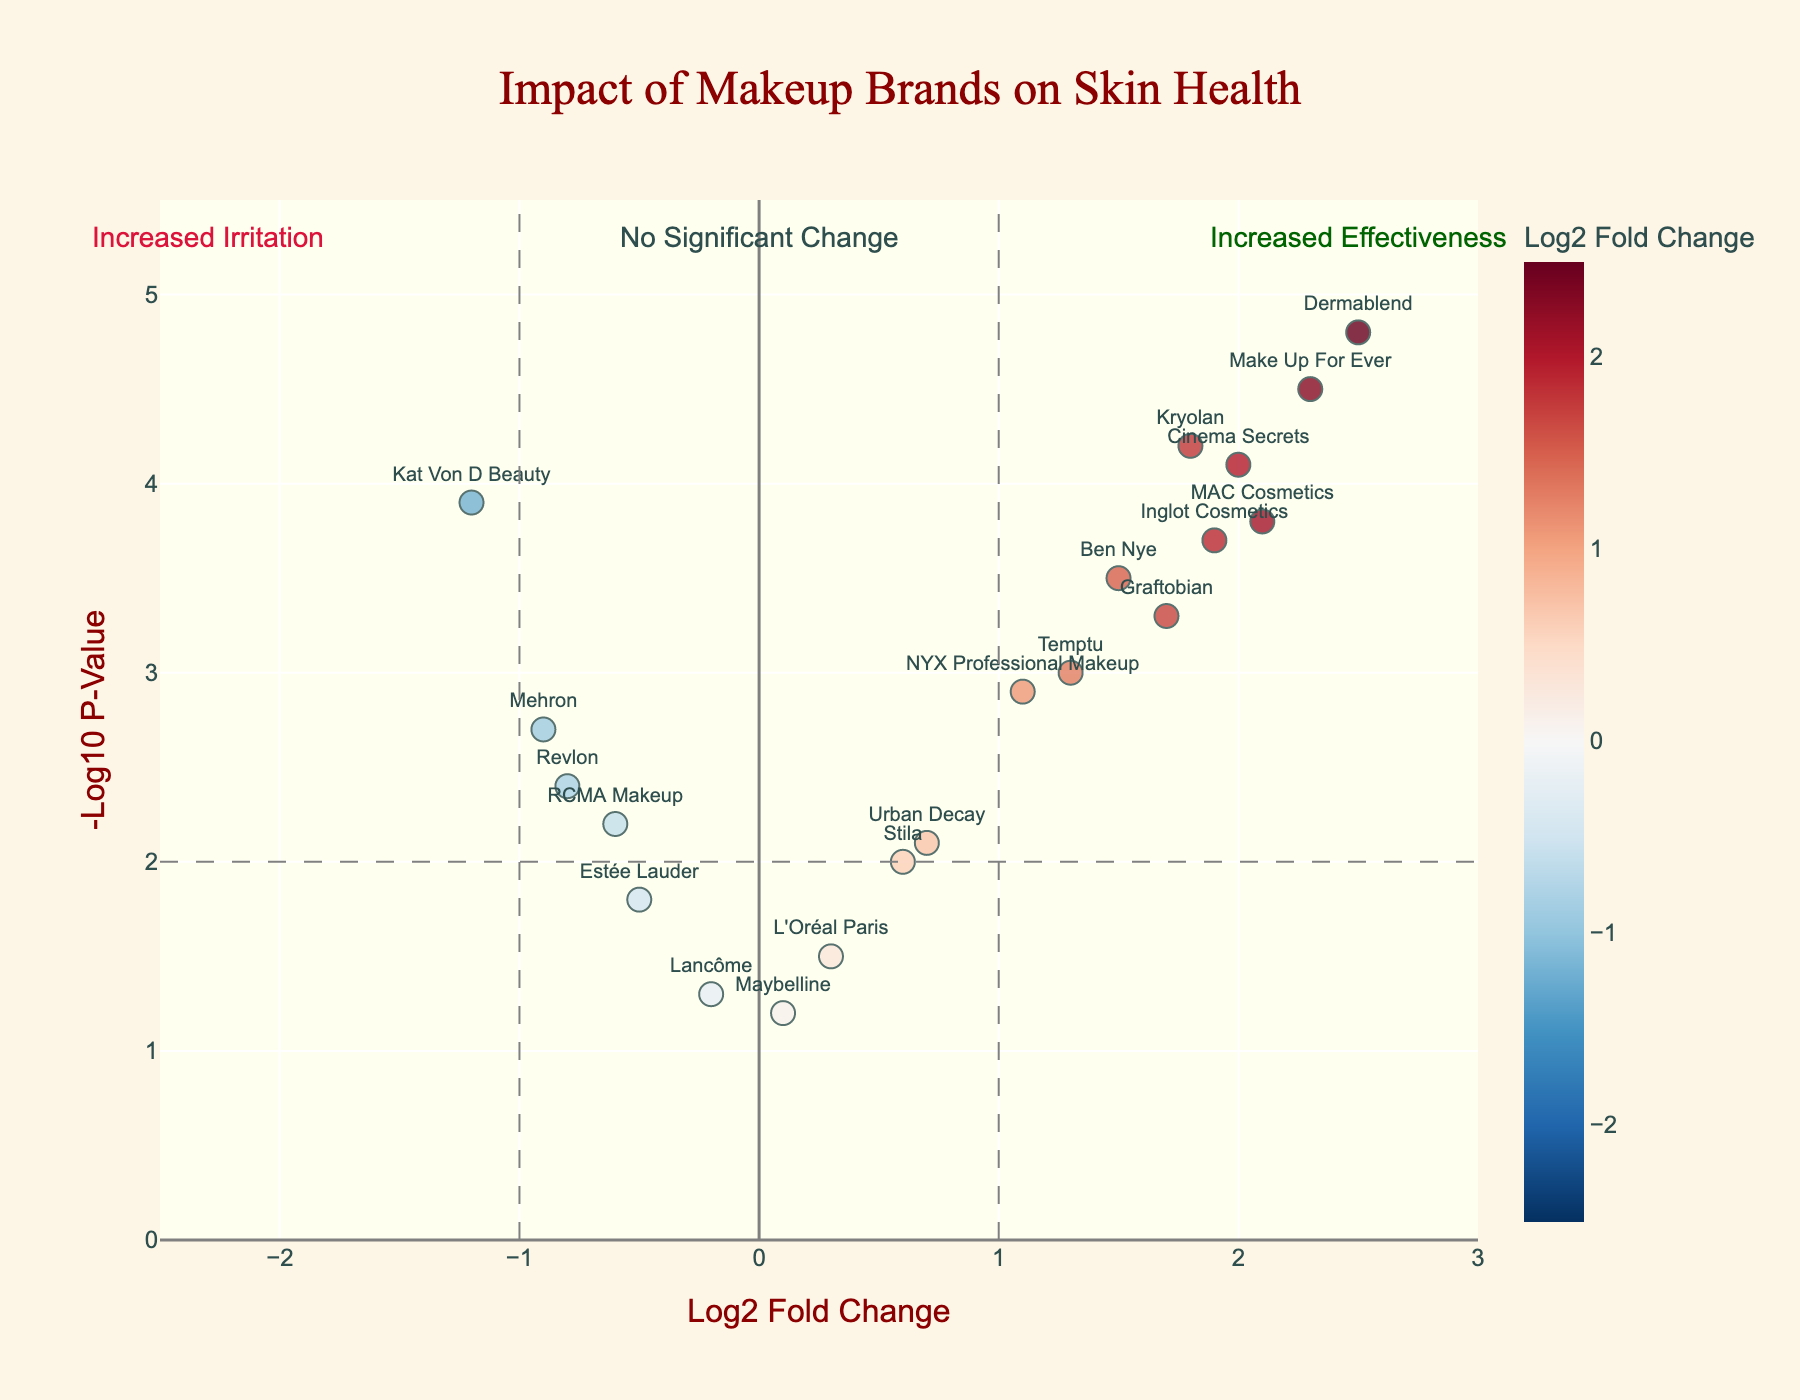What's the title of the plot? The title can be found at the top of the plot presented in a larger, distinctive font. It helps in identifying the main focus of the visualization.
Answer: Impact of Makeup Brands on Skin Health How many brands have a negative Log2 Fold Change? Count all the data points on the left of the vertical line at Log2 Fold Change = 0. These represent the brands with a negative Log2 Fold Change.
Answer: 6 Which brand is represented by the highest NegativeLog10PValue? Identify the data point with the highest y-value in the plot and check the corresponding brand label.
Answer: Dermablend What is the Log2 Fold Change and NegativeLog10PValue for MAC Cosmetics? Locate the data point labeled "MAC Cosmetics" and read off its x and y coordinates on the graph.
Answer: 2.1, 3.8 Which brand has the highest Log2 Fold Change and what does it indicate about its skin health impact? Find the data point with the highest x-value and identify the corresponding brand. A higher Log2 Fold Change indicates increased effectiveness.
Answer: Dermablend, Increased effectiveness How many brands fall into the "Increased Effectiveness" region? Look at the number of data points to the right of the vertical line at Log2 Fold Change = 1 and above the horizontal line at -Log10 P-Value = 2.
Answer: 5 Compare the skin health impact of Urban Decay and Ben Nye. Find the data points for Urban Decay and Ben Nye. Compare their Log2 Fold Change and NegativeLog10PValue to determine which one has a greater and statistically more significant impact.
Answer: Ben Nye is more effective and statistically significant than Urban Decay Which brand has the lowest NegativeLog10PValue and what does it imply? Identify the data point with the lowest y-value and check the corresponding brand. A lower NegativeLog10PValue implies that the result is less statistically significant.
Answer: Maybelline, Less statistically significant What threshold lines are present in the plot and what do they signify? Identify the horizontal and vertical lines within the plot. The thresholds often indicate significant levels of fold change and p-value.
Answer: Vertical thresholds at Log2 Fold Change = -1 and 1; Horizontal threshold at -Log10 P-Value = 2. They signify significant change in effectiveness and irritation factors 